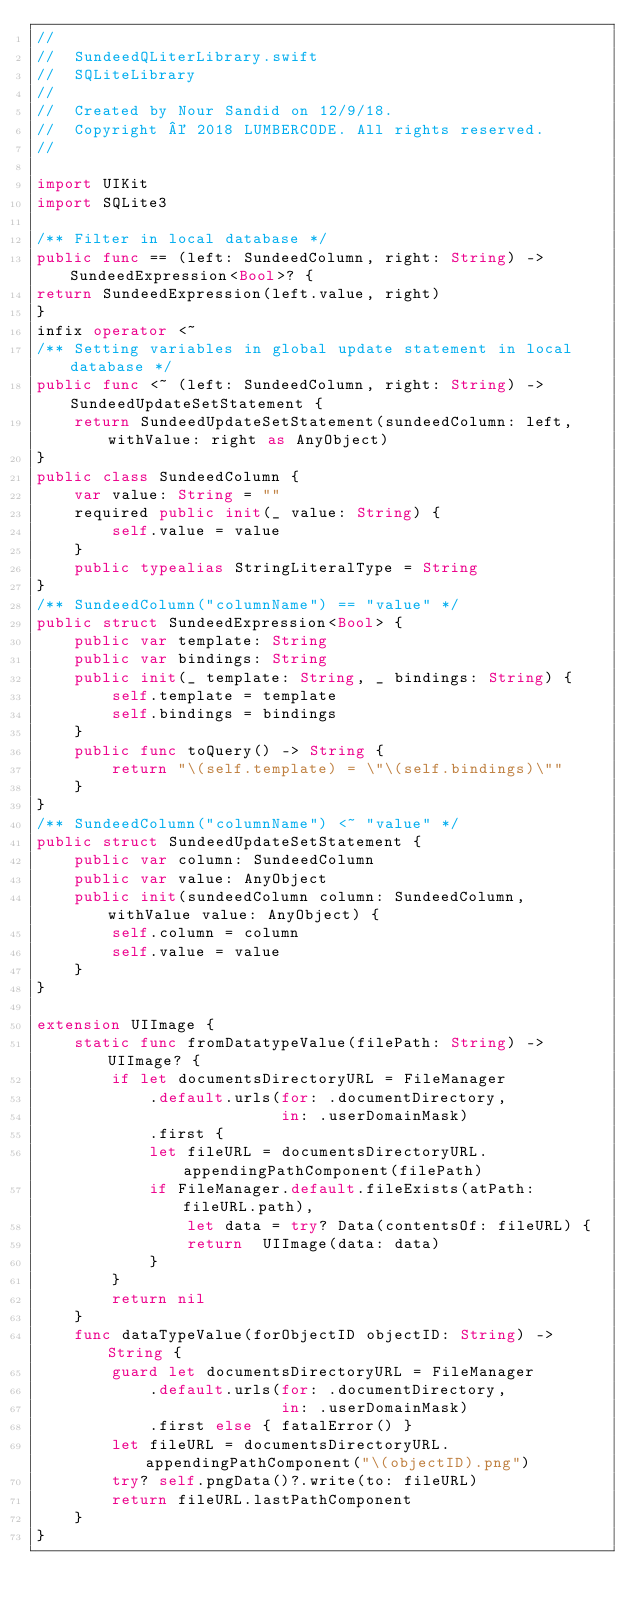Convert code to text. <code><loc_0><loc_0><loc_500><loc_500><_Swift_>//
//  SundeedQLiterLibrary.swift
//  SQLiteLibrary
//
//  Created by Nour Sandid on 12/9/18.
//  Copyright © 2018 LUMBERCODE. All rights reserved.
//

import UIKit
import SQLite3

/** Filter in local database */
public func == (left: SundeedColumn, right: String) -> SundeedExpression<Bool>? {
return SundeedExpression(left.value, right)
}
infix operator <~
/** Setting variables in global update statement in local database */
public func <~ (left: SundeedColumn, right: String) -> SundeedUpdateSetStatement {
    return SundeedUpdateSetStatement(sundeedColumn: left, withValue: right as AnyObject)
}
public class SundeedColumn {
    var value: String = ""
    required public init(_ value: String) {
        self.value = value
    }
    public typealias StringLiteralType = String
}
/** SundeedColumn("columnName") == "value" */
public struct SundeedExpression<Bool> {
    public var template: String
    public var bindings: String
    public init(_ template: String, _ bindings: String) {
        self.template = template
        self.bindings = bindings
    }
    public func toQuery() -> String {
        return "\(self.template) = \"\(self.bindings)\""
    }
}
/** SundeedColumn("columnName") <~ "value" */
public struct SundeedUpdateSetStatement {
    public var column: SundeedColumn
    public var value: AnyObject
    public init(sundeedColumn column: SundeedColumn, withValue value: AnyObject) {
        self.column = column
        self.value = value
    }
}

extension UIImage {
    static func fromDatatypeValue(filePath: String) -> UIImage? {
        if let documentsDirectoryURL = FileManager
            .default.urls(for: .documentDirectory,
                          in: .userDomainMask)
            .first {
            let fileURL = documentsDirectoryURL.appendingPathComponent(filePath)
            if FileManager.default.fileExists(atPath: fileURL.path),
                let data = try? Data(contentsOf: fileURL) {
                return  UIImage(data: data)
            }
        }
        return nil
    }
    func dataTypeValue(forObjectID objectID: String) -> String {
        guard let documentsDirectoryURL = FileManager
            .default.urls(for: .documentDirectory,
                          in: .userDomainMask)
            .first else { fatalError() }
        let fileURL = documentsDirectoryURL.appendingPathComponent("\(objectID).png")
        try? self.pngData()?.write(to: fileURL)
        return fileURL.lastPathComponent
    }
}
</code> 